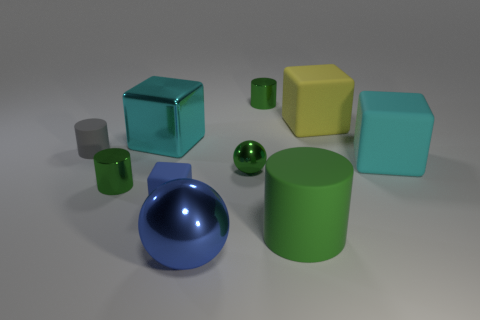The block that is the same size as the gray cylinder is what color?
Your answer should be compact. Blue. There is a big cyan matte object; does it have the same shape as the cyan object that is to the left of the blue metallic object?
Provide a succinct answer. Yes. What number of things are large matte cubes to the right of the big yellow object or green objects in front of the yellow object?
Keep it short and to the point. 4. What is the shape of the thing that is the same color as the big ball?
Your answer should be compact. Cube. There is a large metallic object that is in front of the small gray cylinder; what shape is it?
Make the answer very short. Sphere. Is the shape of the small green thing that is to the left of the large blue thing the same as  the small gray thing?
Provide a succinct answer. Yes. How many objects are either objects on the left side of the blue shiny sphere or big yellow matte spheres?
Provide a succinct answer. 4. What is the color of the big matte thing that is the same shape as the small gray matte thing?
Offer a very short reply. Green. Is there anything else that is the same color as the small matte cylinder?
Your response must be concise. No. There is a blue matte thing left of the tiny green shiny ball; what is its size?
Provide a succinct answer. Small. 